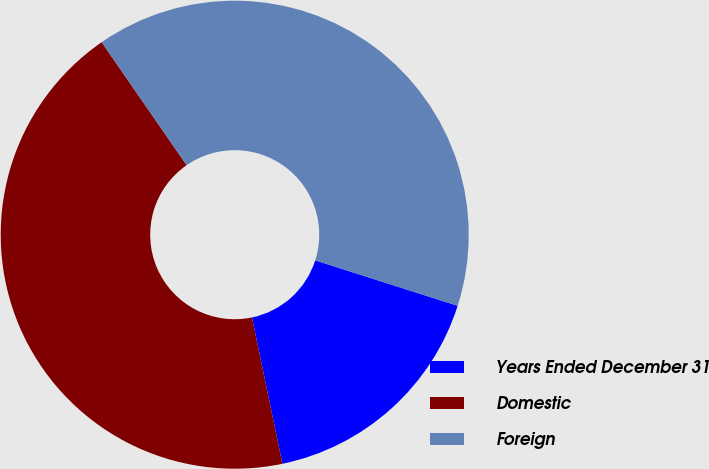Convert chart. <chart><loc_0><loc_0><loc_500><loc_500><pie_chart><fcel>Years Ended December 31<fcel>Domestic<fcel>Foreign<nl><fcel>16.82%<fcel>43.64%<fcel>39.54%<nl></chart> 